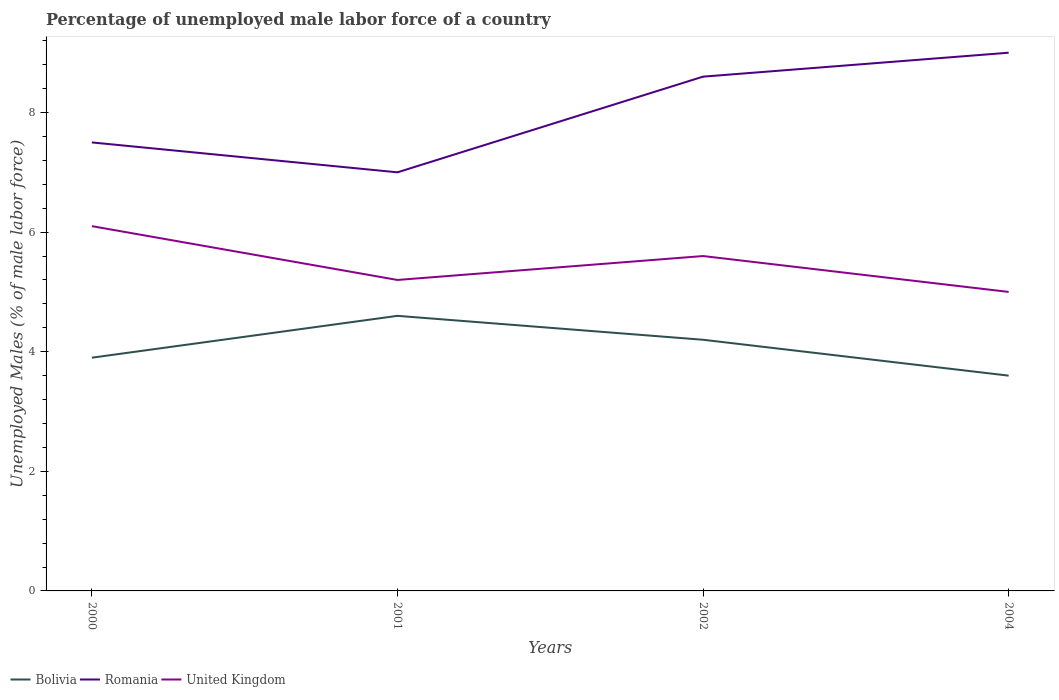Does the line corresponding to United Kingdom intersect with the line corresponding to Bolivia?
Your answer should be compact. No. Is the number of lines equal to the number of legend labels?
Offer a very short reply. Yes. Across all years, what is the maximum percentage of unemployed male labor force in Bolivia?
Give a very brief answer. 3.6. What is the total percentage of unemployed male labor force in United Kingdom in the graph?
Offer a very short reply. -0.4. What is the difference between the highest and the lowest percentage of unemployed male labor force in United Kingdom?
Your answer should be very brief. 2. Is the percentage of unemployed male labor force in Bolivia strictly greater than the percentage of unemployed male labor force in United Kingdom over the years?
Offer a terse response. Yes. What is the difference between two consecutive major ticks on the Y-axis?
Your response must be concise. 2. Does the graph contain grids?
Your answer should be very brief. No. Where does the legend appear in the graph?
Make the answer very short. Bottom left. How many legend labels are there?
Make the answer very short. 3. How are the legend labels stacked?
Make the answer very short. Horizontal. What is the title of the graph?
Provide a short and direct response. Percentage of unemployed male labor force of a country. Does "Canada" appear as one of the legend labels in the graph?
Your response must be concise. No. What is the label or title of the X-axis?
Provide a succinct answer. Years. What is the label or title of the Y-axis?
Offer a very short reply. Unemployed Males (% of male labor force). What is the Unemployed Males (% of male labor force) in Bolivia in 2000?
Ensure brevity in your answer.  3.9. What is the Unemployed Males (% of male labor force) of United Kingdom in 2000?
Keep it short and to the point. 6.1. What is the Unemployed Males (% of male labor force) in Bolivia in 2001?
Give a very brief answer. 4.6. What is the Unemployed Males (% of male labor force) of United Kingdom in 2001?
Offer a very short reply. 5.2. What is the Unemployed Males (% of male labor force) in Bolivia in 2002?
Keep it short and to the point. 4.2. What is the Unemployed Males (% of male labor force) in Romania in 2002?
Provide a succinct answer. 8.6. What is the Unemployed Males (% of male labor force) of United Kingdom in 2002?
Give a very brief answer. 5.6. What is the Unemployed Males (% of male labor force) in Bolivia in 2004?
Your answer should be very brief. 3.6. Across all years, what is the maximum Unemployed Males (% of male labor force) of Bolivia?
Make the answer very short. 4.6. Across all years, what is the maximum Unemployed Males (% of male labor force) in Romania?
Ensure brevity in your answer.  9. Across all years, what is the maximum Unemployed Males (% of male labor force) in United Kingdom?
Provide a short and direct response. 6.1. Across all years, what is the minimum Unemployed Males (% of male labor force) in Bolivia?
Your answer should be very brief. 3.6. Across all years, what is the minimum Unemployed Males (% of male labor force) in United Kingdom?
Give a very brief answer. 5. What is the total Unemployed Males (% of male labor force) of Bolivia in the graph?
Give a very brief answer. 16.3. What is the total Unemployed Males (% of male labor force) in Romania in the graph?
Provide a succinct answer. 32.1. What is the total Unemployed Males (% of male labor force) in United Kingdom in the graph?
Your response must be concise. 21.9. What is the difference between the Unemployed Males (% of male labor force) in Bolivia in 2000 and that in 2002?
Keep it short and to the point. -0.3. What is the difference between the Unemployed Males (% of male labor force) of United Kingdom in 2000 and that in 2002?
Offer a very short reply. 0.5. What is the difference between the Unemployed Males (% of male labor force) of Romania in 2000 and that in 2004?
Your response must be concise. -1.5. What is the difference between the Unemployed Males (% of male labor force) in Bolivia in 2001 and that in 2002?
Your answer should be very brief. 0.4. What is the difference between the Unemployed Males (% of male labor force) of United Kingdom in 2001 and that in 2002?
Offer a terse response. -0.4. What is the difference between the Unemployed Males (% of male labor force) of Bolivia in 2001 and that in 2004?
Give a very brief answer. 1. What is the difference between the Unemployed Males (% of male labor force) of Bolivia in 2002 and that in 2004?
Keep it short and to the point. 0.6. What is the difference between the Unemployed Males (% of male labor force) of Bolivia in 2000 and the Unemployed Males (% of male labor force) of Romania in 2001?
Keep it short and to the point. -3.1. What is the difference between the Unemployed Males (% of male labor force) of Bolivia in 2000 and the Unemployed Males (% of male labor force) of United Kingdom in 2001?
Your answer should be very brief. -1.3. What is the difference between the Unemployed Males (% of male labor force) of Bolivia in 2000 and the Unemployed Males (% of male labor force) of Romania in 2002?
Offer a terse response. -4.7. What is the difference between the Unemployed Males (% of male labor force) of Romania in 2000 and the Unemployed Males (% of male labor force) of United Kingdom in 2004?
Ensure brevity in your answer.  2.5. What is the difference between the Unemployed Males (% of male labor force) of Bolivia in 2001 and the Unemployed Males (% of male labor force) of United Kingdom in 2002?
Offer a terse response. -1. What is the difference between the Unemployed Males (% of male labor force) in Romania in 2001 and the Unemployed Males (% of male labor force) in United Kingdom in 2002?
Provide a short and direct response. 1.4. What is the difference between the Unemployed Males (% of male labor force) in Bolivia in 2001 and the Unemployed Males (% of male labor force) in Romania in 2004?
Offer a very short reply. -4.4. What is the difference between the Unemployed Males (% of male labor force) in Romania in 2001 and the Unemployed Males (% of male labor force) in United Kingdom in 2004?
Make the answer very short. 2. What is the difference between the Unemployed Males (% of male labor force) in Bolivia in 2002 and the Unemployed Males (% of male labor force) in United Kingdom in 2004?
Provide a succinct answer. -0.8. What is the average Unemployed Males (% of male labor force) in Bolivia per year?
Ensure brevity in your answer.  4.08. What is the average Unemployed Males (% of male labor force) in Romania per year?
Your answer should be compact. 8.03. What is the average Unemployed Males (% of male labor force) in United Kingdom per year?
Ensure brevity in your answer.  5.47. In the year 2000, what is the difference between the Unemployed Males (% of male labor force) of Bolivia and Unemployed Males (% of male labor force) of Romania?
Give a very brief answer. -3.6. In the year 2000, what is the difference between the Unemployed Males (% of male labor force) of Bolivia and Unemployed Males (% of male labor force) of United Kingdom?
Provide a short and direct response. -2.2. In the year 2001, what is the difference between the Unemployed Males (% of male labor force) in Bolivia and Unemployed Males (% of male labor force) in Romania?
Make the answer very short. -2.4. In the year 2004, what is the difference between the Unemployed Males (% of male labor force) of Romania and Unemployed Males (% of male labor force) of United Kingdom?
Provide a succinct answer. 4. What is the ratio of the Unemployed Males (% of male labor force) of Bolivia in 2000 to that in 2001?
Provide a short and direct response. 0.85. What is the ratio of the Unemployed Males (% of male labor force) of Romania in 2000 to that in 2001?
Keep it short and to the point. 1.07. What is the ratio of the Unemployed Males (% of male labor force) in United Kingdom in 2000 to that in 2001?
Offer a terse response. 1.17. What is the ratio of the Unemployed Males (% of male labor force) in Bolivia in 2000 to that in 2002?
Give a very brief answer. 0.93. What is the ratio of the Unemployed Males (% of male labor force) in Romania in 2000 to that in 2002?
Your answer should be compact. 0.87. What is the ratio of the Unemployed Males (% of male labor force) of United Kingdom in 2000 to that in 2002?
Provide a succinct answer. 1.09. What is the ratio of the Unemployed Males (% of male labor force) in Bolivia in 2000 to that in 2004?
Ensure brevity in your answer.  1.08. What is the ratio of the Unemployed Males (% of male labor force) in Romania in 2000 to that in 2004?
Your response must be concise. 0.83. What is the ratio of the Unemployed Males (% of male labor force) in United Kingdom in 2000 to that in 2004?
Give a very brief answer. 1.22. What is the ratio of the Unemployed Males (% of male labor force) of Bolivia in 2001 to that in 2002?
Your response must be concise. 1.1. What is the ratio of the Unemployed Males (% of male labor force) of Romania in 2001 to that in 2002?
Keep it short and to the point. 0.81. What is the ratio of the Unemployed Males (% of male labor force) of United Kingdom in 2001 to that in 2002?
Make the answer very short. 0.93. What is the ratio of the Unemployed Males (% of male labor force) in Bolivia in 2001 to that in 2004?
Offer a very short reply. 1.28. What is the ratio of the Unemployed Males (% of male labor force) of Romania in 2001 to that in 2004?
Keep it short and to the point. 0.78. What is the ratio of the Unemployed Males (% of male labor force) in United Kingdom in 2001 to that in 2004?
Provide a short and direct response. 1.04. What is the ratio of the Unemployed Males (% of male labor force) of Bolivia in 2002 to that in 2004?
Provide a short and direct response. 1.17. What is the ratio of the Unemployed Males (% of male labor force) of Romania in 2002 to that in 2004?
Your response must be concise. 0.96. What is the ratio of the Unemployed Males (% of male labor force) of United Kingdom in 2002 to that in 2004?
Provide a succinct answer. 1.12. What is the difference between the highest and the second highest Unemployed Males (% of male labor force) of Romania?
Make the answer very short. 0.4. 